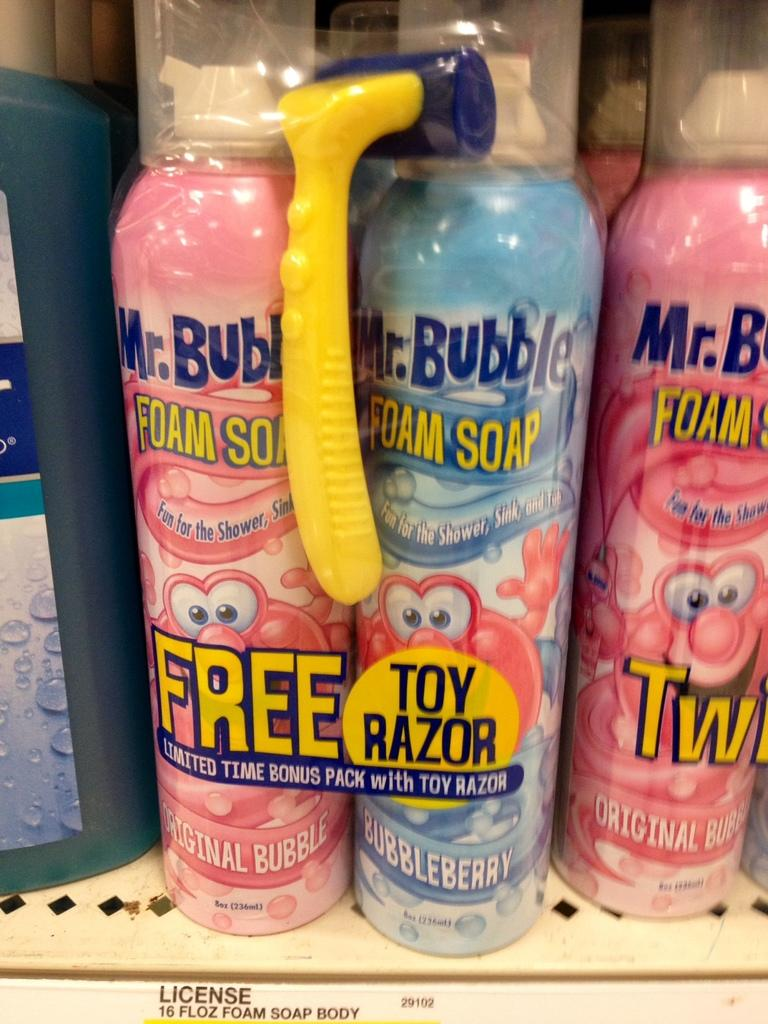<image>
Summarize the visual content of the image. Bottles of Mr. Bubble foam soap sitting on a store shelf. 